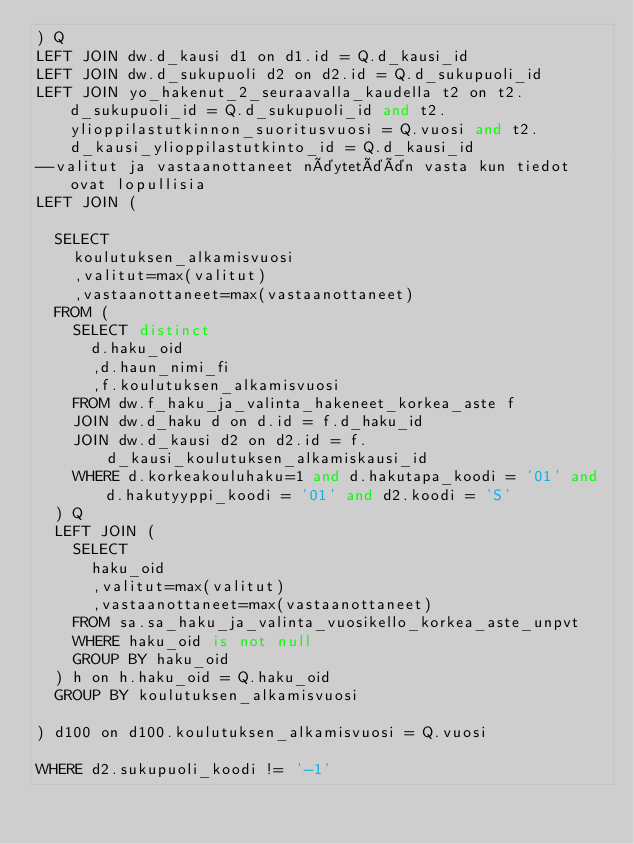Convert code to text. <code><loc_0><loc_0><loc_500><loc_500><_SQL_>) Q
LEFT JOIN dw.d_kausi d1 on d1.id = Q.d_kausi_id
LEFT JOIN dw.d_sukupuoli d2 on d2.id = Q.d_sukupuoli_id
LEFT JOIN yo_hakenut_2_seuraavalla_kaudella t2 on t2.d_sukupuoli_id = Q.d_sukupuoli_id and t2.ylioppilastutkinnon_suoritusvuosi = Q.vuosi and t2.d_kausi_ylioppilastutkinto_id = Q.d_kausi_id
--valitut ja vastaanottaneet näytetään vasta kun tiedot ovat lopullisia
LEFT JOIN (

	SELECT
		koulutuksen_alkamisvuosi
		,valitut=max(valitut)
		,vastaanottaneet=max(vastaanottaneet)
	FROM (
		SELECT distinct
			d.haku_oid
			,d.haun_nimi_fi
			,f.koulutuksen_alkamisvuosi
		FROM dw.f_haku_ja_valinta_hakeneet_korkea_aste f
		JOIN dw.d_haku d on d.id = f.d_haku_id
		JOIN dw.d_kausi d2 on d2.id = f.d_kausi_koulutuksen_alkamiskausi_id
		WHERE d.korkeakouluhaku=1 and d.hakutapa_koodi = '01' and d.hakutyyppi_koodi = '01' and d2.koodi = 'S'
	) Q
	LEFT JOIN (
		SELECT 
			haku_oid
			,valitut=max(valitut)
			,vastaanottaneet=max(vastaanottaneet)
		FROM sa.sa_haku_ja_valinta_vuosikello_korkea_aste_unpvt
		WHERE haku_oid is not null
		GROUP BY haku_oid
	) h on h.haku_oid = Q.haku_oid
	GROUP BY koulutuksen_alkamisvuosi

) d100 on d100.koulutuksen_alkamisvuosi = Q.vuosi

WHERE d2.sukupuoli_koodi != '-1'
</code> 